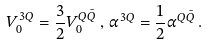<formula> <loc_0><loc_0><loc_500><loc_500>V _ { 0 } ^ { 3 Q } = \frac { 3 } { 2 } V _ { 0 } ^ { Q \bar { Q } } \, , \, \alpha ^ { 3 Q } = \frac { 1 } { 2 } \alpha ^ { Q \bar { Q } } \, .</formula> 